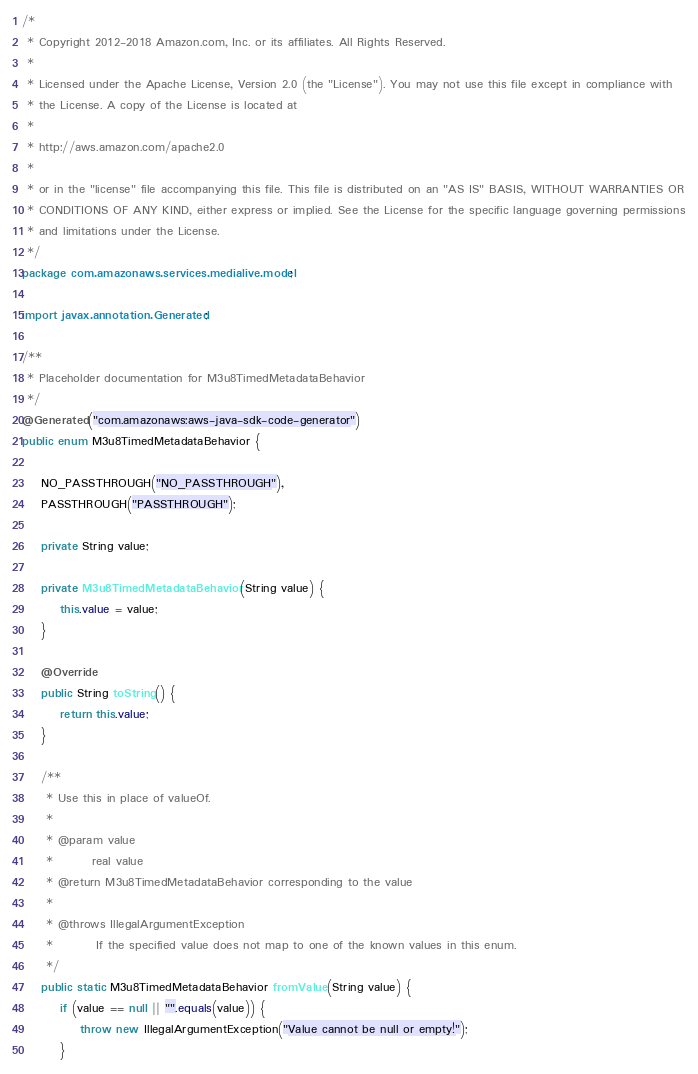Convert code to text. <code><loc_0><loc_0><loc_500><loc_500><_Java_>/*
 * Copyright 2012-2018 Amazon.com, Inc. or its affiliates. All Rights Reserved.
 * 
 * Licensed under the Apache License, Version 2.0 (the "License"). You may not use this file except in compliance with
 * the License. A copy of the License is located at
 * 
 * http://aws.amazon.com/apache2.0
 * 
 * or in the "license" file accompanying this file. This file is distributed on an "AS IS" BASIS, WITHOUT WARRANTIES OR
 * CONDITIONS OF ANY KIND, either express or implied. See the License for the specific language governing permissions
 * and limitations under the License.
 */
package com.amazonaws.services.medialive.model;

import javax.annotation.Generated;

/**
 * Placeholder documentation for M3u8TimedMetadataBehavior
 */
@Generated("com.amazonaws:aws-java-sdk-code-generator")
public enum M3u8TimedMetadataBehavior {

    NO_PASSTHROUGH("NO_PASSTHROUGH"),
    PASSTHROUGH("PASSTHROUGH");

    private String value;

    private M3u8TimedMetadataBehavior(String value) {
        this.value = value;
    }

    @Override
    public String toString() {
        return this.value;
    }

    /**
     * Use this in place of valueOf.
     *
     * @param value
     *        real value
     * @return M3u8TimedMetadataBehavior corresponding to the value
     *
     * @throws IllegalArgumentException
     *         If the specified value does not map to one of the known values in this enum.
     */
    public static M3u8TimedMetadataBehavior fromValue(String value) {
        if (value == null || "".equals(value)) {
            throw new IllegalArgumentException("Value cannot be null or empty!");
        }
</code> 